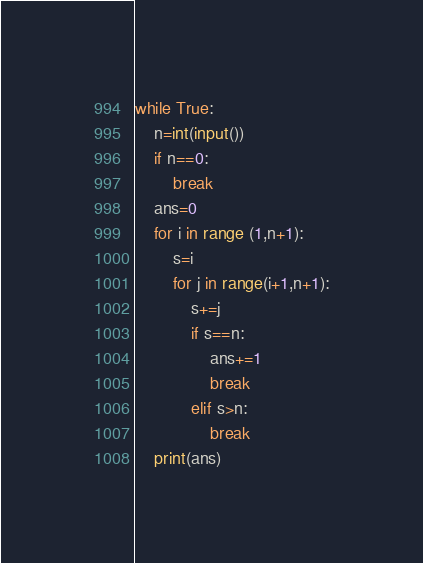<code> <loc_0><loc_0><loc_500><loc_500><_Python_>while True:
    n=int(input())
    if n==0:
        break
    ans=0
    for i in range (1,n+1):
        s=i
        for j in range(i+1,n+1):
            s+=j
            if s==n:
                ans+=1
                break
            elif s>n:
                break
    print(ans)
</code> 